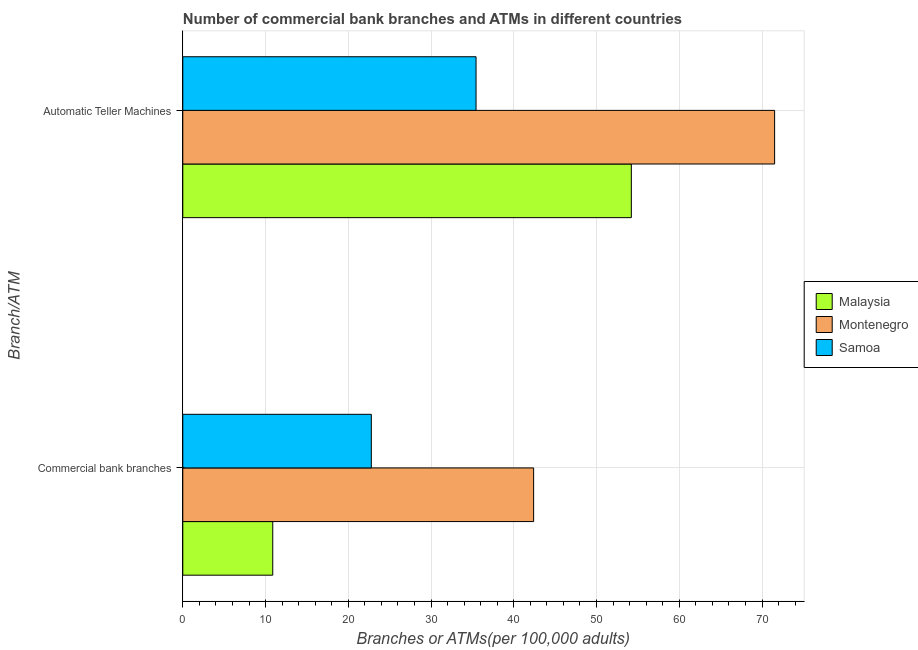How many groups of bars are there?
Offer a very short reply. 2. Are the number of bars per tick equal to the number of legend labels?
Give a very brief answer. Yes. What is the label of the 1st group of bars from the top?
Offer a very short reply. Automatic Teller Machines. What is the number of atms in Samoa?
Keep it short and to the point. 35.44. Across all countries, what is the maximum number of atms?
Your answer should be very brief. 71.52. Across all countries, what is the minimum number of atms?
Keep it short and to the point. 35.44. In which country was the number of atms maximum?
Offer a terse response. Montenegro. In which country was the number of commercal bank branches minimum?
Offer a very short reply. Malaysia. What is the total number of atms in the graph?
Keep it short and to the point. 161.16. What is the difference between the number of atms in Samoa and that in Malaysia?
Give a very brief answer. -18.77. What is the difference between the number of commercal bank branches in Malaysia and the number of atms in Montenegro?
Provide a succinct answer. -60.65. What is the average number of atms per country?
Offer a very short reply. 53.72. What is the difference between the number of commercal bank branches and number of atms in Malaysia?
Give a very brief answer. -43.34. What is the ratio of the number of atms in Montenegro to that in Malaysia?
Your response must be concise. 1.32. Is the number of atms in Montenegro less than that in Malaysia?
Provide a succinct answer. No. In how many countries, is the number of commercal bank branches greater than the average number of commercal bank branches taken over all countries?
Provide a short and direct response. 1. What does the 3rd bar from the top in Commercial bank branches represents?
Your answer should be compact. Malaysia. What does the 1st bar from the bottom in Automatic Teller Machines represents?
Your answer should be compact. Malaysia. How many bars are there?
Make the answer very short. 6. Does the graph contain any zero values?
Provide a short and direct response. No. Where does the legend appear in the graph?
Offer a very short reply. Center right. How are the legend labels stacked?
Your answer should be very brief. Vertical. What is the title of the graph?
Make the answer very short. Number of commercial bank branches and ATMs in different countries. Does "Turkmenistan" appear as one of the legend labels in the graph?
Offer a terse response. No. What is the label or title of the X-axis?
Make the answer very short. Branches or ATMs(per 100,0 adults). What is the label or title of the Y-axis?
Make the answer very short. Branch/ATM. What is the Branches or ATMs(per 100,000 adults) of Malaysia in Commercial bank branches?
Offer a terse response. 10.87. What is the Branches or ATMs(per 100,000 adults) of Montenegro in Commercial bank branches?
Offer a very short reply. 42.4. What is the Branches or ATMs(per 100,000 adults) of Samoa in Commercial bank branches?
Ensure brevity in your answer.  22.78. What is the Branches or ATMs(per 100,000 adults) in Malaysia in Automatic Teller Machines?
Your answer should be very brief. 54.21. What is the Branches or ATMs(per 100,000 adults) in Montenegro in Automatic Teller Machines?
Your response must be concise. 71.52. What is the Branches or ATMs(per 100,000 adults) in Samoa in Automatic Teller Machines?
Provide a short and direct response. 35.44. Across all Branch/ATM, what is the maximum Branches or ATMs(per 100,000 adults) of Malaysia?
Provide a short and direct response. 54.21. Across all Branch/ATM, what is the maximum Branches or ATMs(per 100,000 adults) in Montenegro?
Keep it short and to the point. 71.52. Across all Branch/ATM, what is the maximum Branches or ATMs(per 100,000 adults) in Samoa?
Give a very brief answer. 35.44. Across all Branch/ATM, what is the minimum Branches or ATMs(per 100,000 adults) in Malaysia?
Ensure brevity in your answer.  10.87. Across all Branch/ATM, what is the minimum Branches or ATMs(per 100,000 adults) of Montenegro?
Make the answer very short. 42.4. Across all Branch/ATM, what is the minimum Branches or ATMs(per 100,000 adults) of Samoa?
Ensure brevity in your answer.  22.78. What is the total Branches or ATMs(per 100,000 adults) of Malaysia in the graph?
Offer a very short reply. 65.08. What is the total Branches or ATMs(per 100,000 adults) in Montenegro in the graph?
Give a very brief answer. 113.91. What is the total Branches or ATMs(per 100,000 adults) in Samoa in the graph?
Your answer should be very brief. 58.22. What is the difference between the Branches or ATMs(per 100,000 adults) of Malaysia in Commercial bank branches and that in Automatic Teller Machines?
Make the answer very short. -43.34. What is the difference between the Branches or ATMs(per 100,000 adults) in Montenegro in Commercial bank branches and that in Automatic Teller Machines?
Offer a terse response. -29.12. What is the difference between the Branches or ATMs(per 100,000 adults) of Samoa in Commercial bank branches and that in Automatic Teller Machines?
Your answer should be compact. -12.66. What is the difference between the Branches or ATMs(per 100,000 adults) of Malaysia in Commercial bank branches and the Branches or ATMs(per 100,000 adults) of Montenegro in Automatic Teller Machines?
Your answer should be compact. -60.65. What is the difference between the Branches or ATMs(per 100,000 adults) in Malaysia in Commercial bank branches and the Branches or ATMs(per 100,000 adults) in Samoa in Automatic Teller Machines?
Give a very brief answer. -24.57. What is the difference between the Branches or ATMs(per 100,000 adults) of Montenegro in Commercial bank branches and the Branches or ATMs(per 100,000 adults) of Samoa in Automatic Teller Machines?
Give a very brief answer. 6.96. What is the average Branches or ATMs(per 100,000 adults) in Malaysia per Branch/ATM?
Offer a very short reply. 32.54. What is the average Branches or ATMs(per 100,000 adults) in Montenegro per Branch/ATM?
Give a very brief answer. 56.96. What is the average Branches or ATMs(per 100,000 adults) of Samoa per Branch/ATM?
Offer a very short reply. 29.11. What is the difference between the Branches or ATMs(per 100,000 adults) of Malaysia and Branches or ATMs(per 100,000 adults) of Montenegro in Commercial bank branches?
Give a very brief answer. -31.53. What is the difference between the Branches or ATMs(per 100,000 adults) of Malaysia and Branches or ATMs(per 100,000 adults) of Samoa in Commercial bank branches?
Provide a short and direct response. -11.91. What is the difference between the Branches or ATMs(per 100,000 adults) of Montenegro and Branches or ATMs(per 100,000 adults) of Samoa in Commercial bank branches?
Your answer should be compact. 19.61. What is the difference between the Branches or ATMs(per 100,000 adults) in Malaysia and Branches or ATMs(per 100,000 adults) in Montenegro in Automatic Teller Machines?
Your answer should be compact. -17.31. What is the difference between the Branches or ATMs(per 100,000 adults) of Malaysia and Branches or ATMs(per 100,000 adults) of Samoa in Automatic Teller Machines?
Your response must be concise. 18.77. What is the difference between the Branches or ATMs(per 100,000 adults) in Montenegro and Branches or ATMs(per 100,000 adults) in Samoa in Automatic Teller Machines?
Give a very brief answer. 36.08. What is the ratio of the Branches or ATMs(per 100,000 adults) of Malaysia in Commercial bank branches to that in Automatic Teller Machines?
Your response must be concise. 0.2. What is the ratio of the Branches or ATMs(per 100,000 adults) in Montenegro in Commercial bank branches to that in Automatic Teller Machines?
Give a very brief answer. 0.59. What is the ratio of the Branches or ATMs(per 100,000 adults) of Samoa in Commercial bank branches to that in Automatic Teller Machines?
Make the answer very short. 0.64. What is the difference between the highest and the second highest Branches or ATMs(per 100,000 adults) in Malaysia?
Your response must be concise. 43.34. What is the difference between the highest and the second highest Branches or ATMs(per 100,000 adults) of Montenegro?
Keep it short and to the point. 29.12. What is the difference between the highest and the second highest Branches or ATMs(per 100,000 adults) in Samoa?
Your answer should be compact. 12.66. What is the difference between the highest and the lowest Branches or ATMs(per 100,000 adults) of Malaysia?
Offer a terse response. 43.34. What is the difference between the highest and the lowest Branches or ATMs(per 100,000 adults) of Montenegro?
Your response must be concise. 29.12. What is the difference between the highest and the lowest Branches or ATMs(per 100,000 adults) of Samoa?
Give a very brief answer. 12.66. 